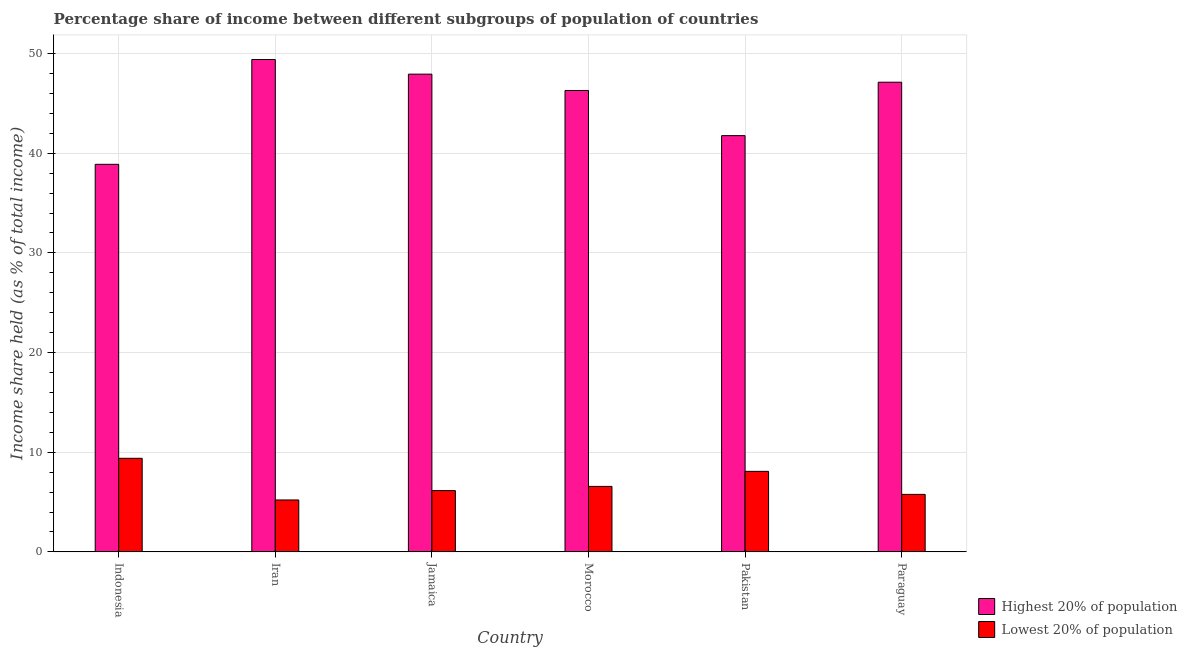How many different coloured bars are there?
Ensure brevity in your answer.  2. How many groups of bars are there?
Offer a terse response. 6. How many bars are there on the 6th tick from the left?
Provide a succinct answer. 2. What is the label of the 6th group of bars from the left?
Ensure brevity in your answer.  Paraguay. In how many cases, is the number of bars for a given country not equal to the number of legend labels?
Keep it short and to the point. 0. What is the income share held by highest 20% of the population in Indonesia?
Ensure brevity in your answer.  38.89. Across all countries, what is the maximum income share held by highest 20% of the population?
Keep it short and to the point. 49.41. Across all countries, what is the minimum income share held by lowest 20% of the population?
Ensure brevity in your answer.  5.21. In which country was the income share held by lowest 20% of the population maximum?
Give a very brief answer. Indonesia. In which country was the income share held by lowest 20% of the population minimum?
Your response must be concise. Iran. What is the total income share held by lowest 20% of the population in the graph?
Provide a short and direct response. 41.17. What is the difference between the income share held by highest 20% of the population in Jamaica and that in Morocco?
Keep it short and to the point. 1.64. What is the difference between the income share held by lowest 20% of the population in Iran and the income share held by highest 20% of the population in Morocco?
Keep it short and to the point. -41.09. What is the average income share held by highest 20% of the population per country?
Your answer should be compact. 45.24. What is the difference between the income share held by lowest 20% of the population and income share held by highest 20% of the population in Morocco?
Make the answer very short. -39.73. What is the ratio of the income share held by lowest 20% of the population in Indonesia to that in Jamaica?
Provide a short and direct response. 1.53. What is the difference between the highest and the second highest income share held by lowest 20% of the population?
Your response must be concise. 1.31. What is the difference between the highest and the lowest income share held by lowest 20% of the population?
Keep it short and to the point. 4.18. In how many countries, is the income share held by lowest 20% of the population greater than the average income share held by lowest 20% of the population taken over all countries?
Your answer should be compact. 2. What does the 1st bar from the left in Indonesia represents?
Your answer should be very brief. Highest 20% of population. What does the 2nd bar from the right in Morocco represents?
Provide a succinct answer. Highest 20% of population. How many countries are there in the graph?
Offer a terse response. 6. What is the difference between two consecutive major ticks on the Y-axis?
Offer a very short reply. 10. Are the values on the major ticks of Y-axis written in scientific E-notation?
Keep it short and to the point. No. Does the graph contain any zero values?
Your answer should be very brief. No. Where does the legend appear in the graph?
Keep it short and to the point. Bottom right. How many legend labels are there?
Provide a short and direct response. 2. What is the title of the graph?
Give a very brief answer. Percentage share of income between different subgroups of population of countries. Does "ODA received" appear as one of the legend labels in the graph?
Your answer should be very brief. No. What is the label or title of the Y-axis?
Keep it short and to the point. Income share held (as % of total income). What is the Income share held (as % of total income) of Highest 20% of population in Indonesia?
Give a very brief answer. 38.89. What is the Income share held (as % of total income) in Lowest 20% of population in Indonesia?
Give a very brief answer. 9.39. What is the Income share held (as % of total income) in Highest 20% of population in Iran?
Your answer should be compact. 49.41. What is the Income share held (as % of total income) of Lowest 20% of population in Iran?
Offer a very short reply. 5.21. What is the Income share held (as % of total income) in Highest 20% of population in Jamaica?
Your response must be concise. 47.94. What is the Income share held (as % of total income) of Lowest 20% of population in Jamaica?
Give a very brief answer. 6.15. What is the Income share held (as % of total income) of Highest 20% of population in Morocco?
Give a very brief answer. 46.3. What is the Income share held (as % of total income) in Lowest 20% of population in Morocco?
Make the answer very short. 6.57. What is the Income share held (as % of total income) in Highest 20% of population in Pakistan?
Provide a short and direct response. 41.77. What is the Income share held (as % of total income) of Lowest 20% of population in Pakistan?
Provide a short and direct response. 8.08. What is the Income share held (as % of total income) in Highest 20% of population in Paraguay?
Offer a terse response. 47.13. What is the Income share held (as % of total income) of Lowest 20% of population in Paraguay?
Offer a terse response. 5.77. Across all countries, what is the maximum Income share held (as % of total income) of Highest 20% of population?
Your answer should be compact. 49.41. Across all countries, what is the maximum Income share held (as % of total income) of Lowest 20% of population?
Ensure brevity in your answer.  9.39. Across all countries, what is the minimum Income share held (as % of total income) in Highest 20% of population?
Ensure brevity in your answer.  38.89. Across all countries, what is the minimum Income share held (as % of total income) of Lowest 20% of population?
Keep it short and to the point. 5.21. What is the total Income share held (as % of total income) of Highest 20% of population in the graph?
Provide a short and direct response. 271.44. What is the total Income share held (as % of total income) of Lowest 20% of population in the graph?
Give a very brief answer. 41.17. What is the difference between the Income share held (as % of total income) in Highest 20% of population in Indonesia and that in Iran?
Your answer should be compact. -10.52. What is the difference between the Income share held (as % of total income) in Lowest 20% of population in Indonesia and that in Iran?
Offer a very short reply. 4.18. What is the difference between the Income share held (as % of total income) of Highest 20% of population in Indonesia and that in Jamaica?
Offer a terse response. -9.05. What is the difference between the Income share held (as % of total income) in Lowest 20% of population in Indonesia and that in Jamaica?
Your answer should be compact. 3.24. What is the difference between the Income share held (as % of total income) in Highest 20% of population in Indonesia and that in Morocco?
Keep it short and to the point. -7.41. What is the difference between the Income share held (as % of total income) in Lowest 20% of population in Indonesia and that in Morocco?
Make the answer very short. 2.82. What is the difference between the Income share held (as % of total income) of Highest 20% of population in Indonesia and that in Pakistan?
Your answer should be compact. -2.88. What is the difference between the Income share held (as % of total income) of Lowest 20% of population in Indonesia and that in Pakistan?
Offer a terse response. 1.31. What is the difference between the Income share held (as % of total income) in Highest 20% of population in Indonesia and that in Paraguay?
Provide a succinct answer. -8.24. What is the difference between the Income share held (as % of total income) of Lowest 20% of population in Indonesia and that in Paraguay?
Offer a terse response. 3.62. What is the difference between the Income share held (as % of total income) in Highest 20% of population in Iran and that in Jamaica?
Offer a terse response. 1.47. What is the difference between the Income share held (as % of total income) in Lowest 20% of population in Iran and that in Jamaica?
Offer a very short reply. -0.94. What is the difference between the Income share held (as % of total income) in Highest 20% of population in Iran and that in Morocco?
Make the answer very short. 3.11. What is the difference between the Income share held (as % of total income) of Lowest 20% of population in Iran and that in Morocco?
Keep it short and to the point. -1.36. What is the difference between the Income share held (as % of total income) in Highest 20% of population in Iran and that in Pakistan?
Offer a very short reply. 7.64. What is the difference between the Income share held (as % of total income) in Lowest 20% of population in Iran and that in Pakistan?
Keep it short and to the point. -2.87. What is the difference between the Income share held (as % of total income) of Highest 20% of population in Iran and that in Paraguay?
Offer a terse response. 2.28. What is the difference between the Income share held (as % of total income) in Lowest 20% of population in Iran and that in Paraguay?
Your answer should be very brief. -0.56. What is the difference between the Income share held (as % of total income) in Highest 20% of population in Jamaica and that in Morocco?
Provide a succinct answer. 1.64. What is the difference between the Income share held (as % of total income) of Lowest 20% of population in Jamaica and that in Morocco?
Provide a succinct answer. -0.42. What is the difference between the Income share held (as % of total income) in Highest 20% of population in Jamaica and that in Pakistan?
Make the answer very short. 6.17. What is the difference between the Income share held (as % of total income) of Lowest 20% of population in Jamaica and that in Pakistan?
Provide a succinct answer. -1.93. What is the difference between the Income share held (as % of total income) in Highest 20% of population in Jamaica and that in Paraguay?
Provide a succinct answer. 0.81. What is the difference between the Income share held (as % of total income) in Lowest 20% of population in Jamaica and that in Paraguay?
Make the answer very short. 0.38. What is the difference between the Income share held (as % of total income) of Highest 20% of population in Morocco and that in Pakistan?
Give a very brief answer. 4.53. What is the difference between the Income share held (as % of total income) of Lowest 20% of population in Morocco and that in Pakistan?
Provide a short and direct response. -1.51. What is the difference between the Income share held (as % of total income) of Highest 20% of population in Morocco and that in Paraguay?
Make the answer very short. -0.83. What is the difference between the Income share held (as % of total income) of Lowest 20% of population in Morocco and that in Paraguay?
Give a very brief answer. 0.8. What is the difference between the Income share held (as % of total income) of Highest 20% of population in Pakistan and that in Paraguay?
Ensure brevity in your answer.  -5.36. What is the difference between the Income share held (as % of total income) in Lowest 20% of population in Pakistan and that in Paraguay?
Give a very brief answer. 2.31. What is the difference between the Income share held (as % of total income) of Highest 20% of population in Indonesia and the Income share held (as % of total income) of Lowest 20% of population in Iran?
Ensure brevity in your answer.  33.68. What is the difference between the Income share held (as % of total income) of Highest 20% of population in Indonesia and the Income share held (as % of total income) of Lowest 20% of population in Jamaica?
Provide a succinct answer. 32.74. What is the difference between the Income share held (as % of total income) of Highest 20% of population in Indonesia and the Income share held (as % of total income) of Lowest 20% of population in Morocco?
Your answer should be very brief. 32.32. What is the difference between the Income share held (as % of total income) of Highest 20% of population in Indonesia and the Income share held (as % of total income) of Lowest 20% of population in Pakistan?
Offer a terse response. 30.81. What is the difference between the Income share held (as % of total income) of Highest 20% of population in Indonesia and the Income share held (as % of total income) of Lowest 20% of population in Paraguay?
Ensure brevity in your answer.  33.12. What is the difference between the Income share held (as % of total income) in Highest 20% of population in Iran and the Income share held (as % of total income) in Lowest 20% of population in Jamaica?
Your response must be concise. 43.26. What is the difference between the Income share held (as % of total income) in Highest 20% of population in Iran and the Income share held (as % of total income) in Lowest 20% of population in Morocco?
Give a very brief answer. 42.84. What is the difference between the Income share held (as % of total income) of Highest 20% of population in Iran and the Income share held (as % of total income) of Lowest 20% of population in Pakistan?
Keep it short and to the point. 41.33. What is the difference between the Income share held (as % of total income) in Highest 20% of population in Iran and the Income share held (as % of total income) in Lowest 20% of population in Paraguay?
Ensure brevity in your answer.  43.64. What is the difference between the Income share held (as % of total income) in Highest 20% of population in Jamaica and the Income share held (as % of total income) in Lowest 20% of population in Morocco?
Your response must be concise. 41.37. What is the difference between the Income share held (as % of total income) in Highest 20% of population in Jamaica and the Income share held (as % of total income) in Lowest 20% of population in Pakistan?
Give a very brief answer. 39.86. What is the difference between the Income share held (as % of total income) of Highest 20% of population in Jamaica and the Income share held (as % of total income) of Lowest 20% of population in Paraguay?
Your answer should be compact. 42.17. What is the difference between the Income share held (as % of total income) of Highest 20% of population in Morocco and the Income share held (as % of total income) of Lowest 20% of population in Pakistan?
Provide a short and direct response. 38.22. What is the difference between the Income share held (as % of total income) of Highest 20% of population in Morocco and the Income share held (as % of total income) of Lowest 20% of population in Paraguay?
Your answer should be compact. 40.53. What is the average Income share held (as % of total income) of Highest 20% of population per country?
Ensure brevity in your answer.  45.24. What is the average Income share held (as % of total income) of Lowest 20% of population per country?
Provide a succinct answer. 6.86. What is the difference between the Income share held (as % of total income) in Highest 20% of population and Income share held (as % of total income) in Lowest 20% of population in Indonesia?
Keep it short and to the point. 29.5. What is the difference between the Income share held (as % of total income) in Highest 20% of population and Income share held (as % of total income) in Lowest 20% of population in Iran?
Your answer should be compact. 44.2. What is the difference between the Income share held (as % of total income) of Highest 20% of population and Income share held (as % of total income) of Lowest 20% of population in Jamaica?
Provide a succinct answer. 41.79. What is the difference between the Income share held (as % of total income) of Highest 20% of population and Income share held (as % of total income) of Lowest 20% of population in Morocco?
Provide a succinct answer. 39.73. What is the difference between the Income share held (as % of total income) in Highest 20% of population and Income share held (as % of total income) in Lowest 20% of population in Pakistan?
Offer a terse response. 33.69. What is the difference between the Income share held (as % of total income) of Highest 20% of population and Income share held (as % of total income) of Lowest 20% of population in Paraguay?
Your answer should be compact. 41.36. What is the ratio of the Income share held (as % of total income) in Highest 20% of population in Indonesia to that in Iran?
Make the answer very short. 0.79. What is the ratio of the Income share held (as % of total income) of Lowest 20% of population in Indonesia to that in Iran?
Offer a terse response. 1.8. What is the ratio of the Income share held (as % of total income) in Highest 20% of population in Indonesia to that in Jamaica?
Your response must be concise. 0.81. What is the ratio of the Income share held (as % of total income) of Lowest 20% of population in Indonesia to that in Jamaica?
Offer a very short reply. 1.53. What is the ratio of the Income share held (as % of total income) in Highest 20% of population in Indonesia to that in Morocco?
Offer a terse response. 0.84. What is the ratio of the Income share held (as % of total income) in Lowest 20% of population in Indonesia to that in Morocco?
Provide a short and direct response. 1.43. What is the ratio of the Income share held (as % of total income) in Highest 20% of population in Indonesia to that in Pakistan?
Make the answer very short. 0.93. What is the ratio of the Income share held (as % of total income) of Lowest 20% of population in Indonesia to that in Pakistan?
Give a very brief answer. 1.16. What is the ratio of the Income share held (as % of total income) in Highest 20% of population in Indonesia to that in Paraguay?
Your answer should be very brief. 0.83. What is the ratio of the Income share held (as % of total income) of Lowest 20% of population in Indonesia to that in Paraguay?
Your answer should be very brief. 1.63. What is the ratio of the Income share held (as % of total income) in Highest 20% of population in Iran to that in Jamaica?
Offer a terse response. 1.03. What is the ratio of the Income share held (as % of total income) of Lowest 20% of population in Iran to that in Jamaica?
Your answer should be compact. 0.85. What is the ratio of the Income share held (as % of total income) in Highest 20% of population in Iran to that in Morocco?
Offer a terse response. 1.07. What is the ratio of the Income share held (as % of total income) of Lowest 20% of population in Iran to that in Morocco?
Keep it short and to the point. 0.79. What is the ratio of the Income share held (as % of total income) of Highest 20% of population in Iran to that in Pakistan?
Offer a terse response. 1.18. What is the ratio of the Income share held (as % of total income) of Lowest 20% of population in Iran to that in Pakistan?
Keep it short and to the point. 0.64. What is the ratio of the Income share held (as % of total income) in Highest 20% of population in Iran to that in Paraguay?
Give a very brief answer. 1.05. What is the ratio of the Income share held (as % of total income) in Lowest 20% of population in Iran to that in Paraguay?
Your answer should be compact. 0.9. What is the ratio of the Income share held (as % of total income) in Highest 20% of population in Jamaica to that in Morocco?
Give a very brief answer. 1.04. What is the ratio of the Income share held (as % of total income) in Lowest 20% of population in Jamaica to that in Morocco?
Keep it short and to the point. 0.94. What is the ratio of the Income share held (as % of total income) of Highest 20% of population in Jamaica to that in Pakistan?
Provide a succinct answer. 1.15. What is the ratio of the Income share held (as % of total income) of Lowest 20% of population in Jamaica to that in Pakistan?
Give a very brief answer. 0.76. What is the ratio of the Income share held (as % of total income) in Highest 20% of population in Jamaica to that in Paraguay?
Your response must be concise. 1.02. What is the ratio of the Income share held (as % of total income) of Lowest 20% of population in Jamaica to that in Paraguay?
Give a very brief answer. 1.07. What is the ratio of the Income share held (as % of total income) of Highest 20% of population in Morocco to that in Pakistan?
Make the answer very short. 1.11. What is the ratio of the Income share held (as % of total income) of Lowest 20% of population in Morocco to that in Pakistan?
Keep it short and to the point. 0.81. What is the ratio of the Income share held (as % of total income) of Highest 20% of population in Morocco to that in Paraguay?
Provide a succinct answer. 0.98. What is the ratio of the Income share held (as % of total income) of Lowest 20% of population in Morocco to that in Paraguay?
Make the answer very short. 1.14. What is the ratio of the Income share held (as % of total income) in Highest 20% of population in Pakistan to that in Paraguay?
Ensure brevity in your answer.  0.89. What is the ratio of the Income share held (as % of total income) in Lowest 20% of population in Pakistan to that in Paraguay?
Provide a short and direct response. 1.4. What is the difference between the highest and the second highest Income share held (as % of total income) of Highest 20% of population?
Your answer should be compact. 1.47. What is the difference between the highest and the second highest Income share held (as % of total income) in Lowest 20% of population?
Your answer should be very brief. 1.31. What is the difference between the highest and the lowest Income share held (as % of total income) of Highest 20% of population?
Offer a terse response. 10.52. What is the difference between the highest and the lowest Income share held (as % of total income) in Lowest 20% of population?
Offer a very short reply. 4.18. 